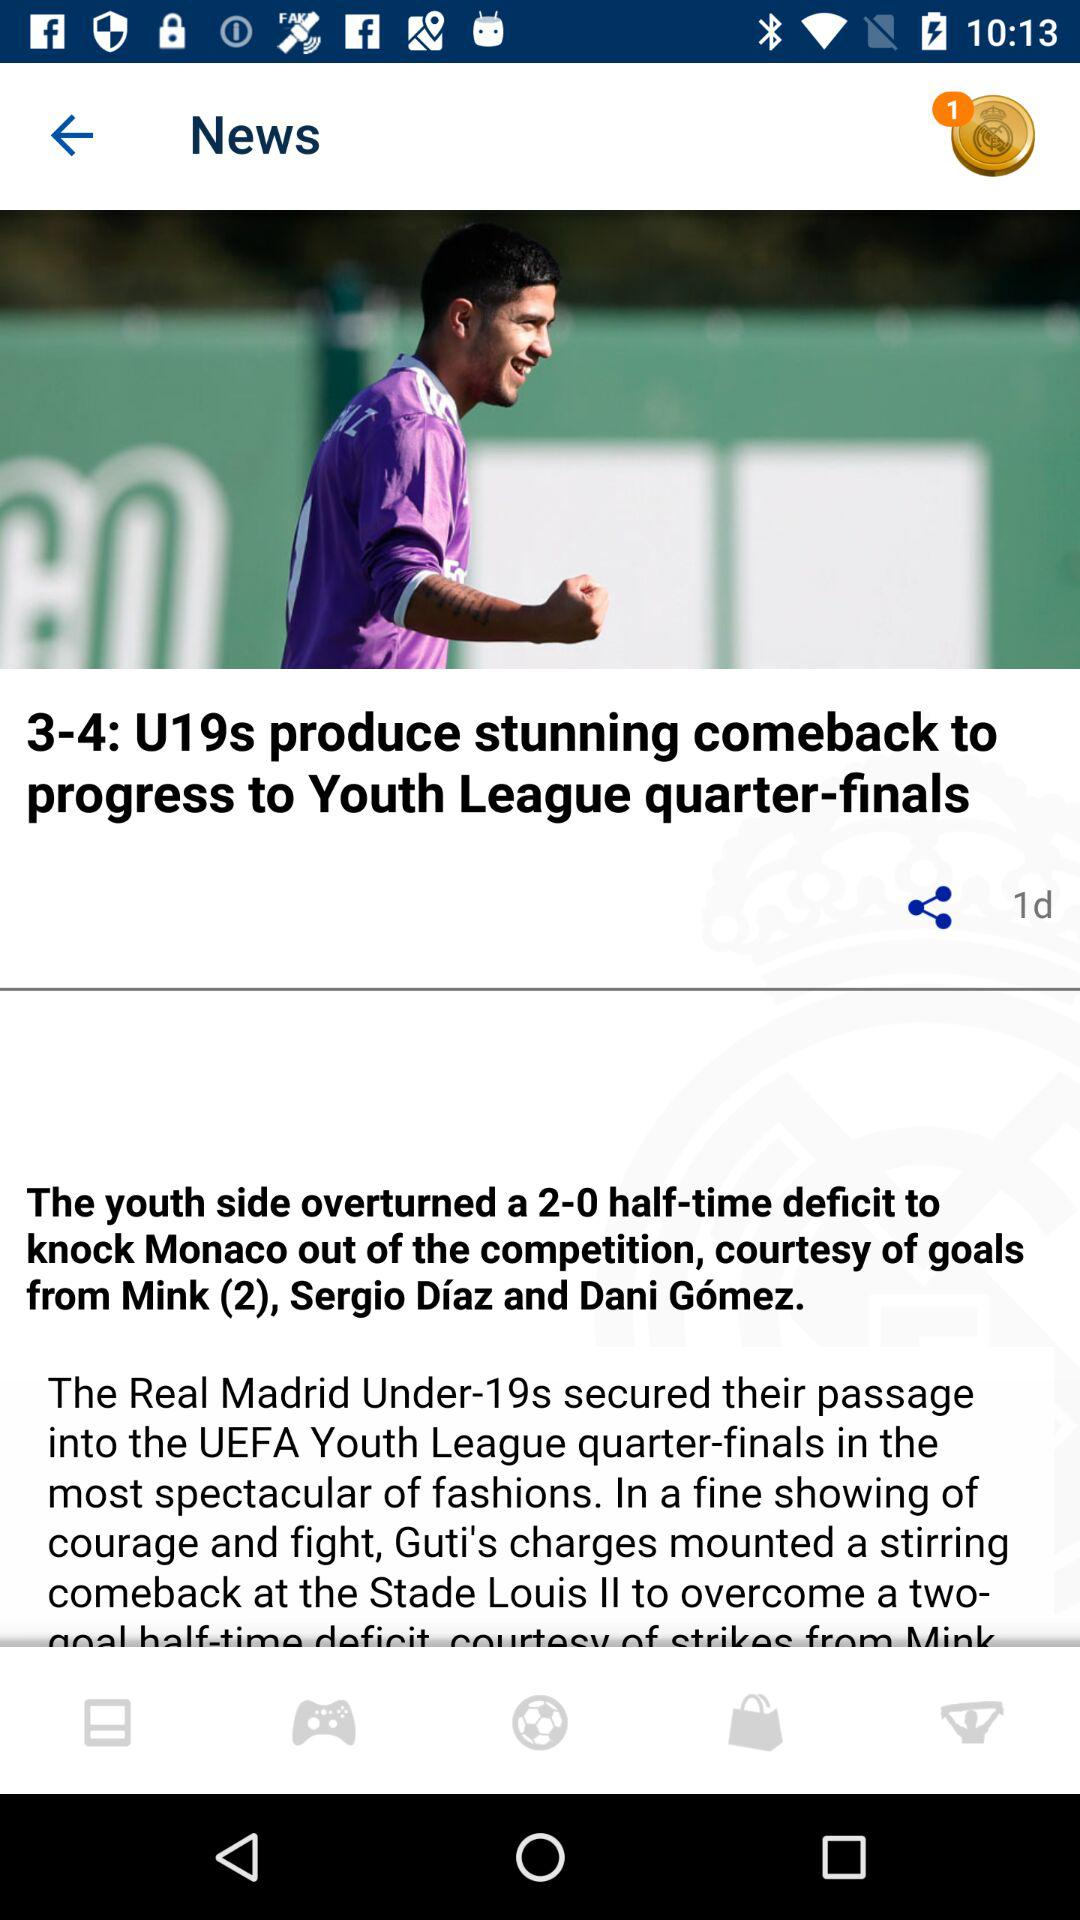How many days ago was the "U19s produce stunning comeback to progress to Youth League quarter-finals" posted? It was posted 1 day ago. 